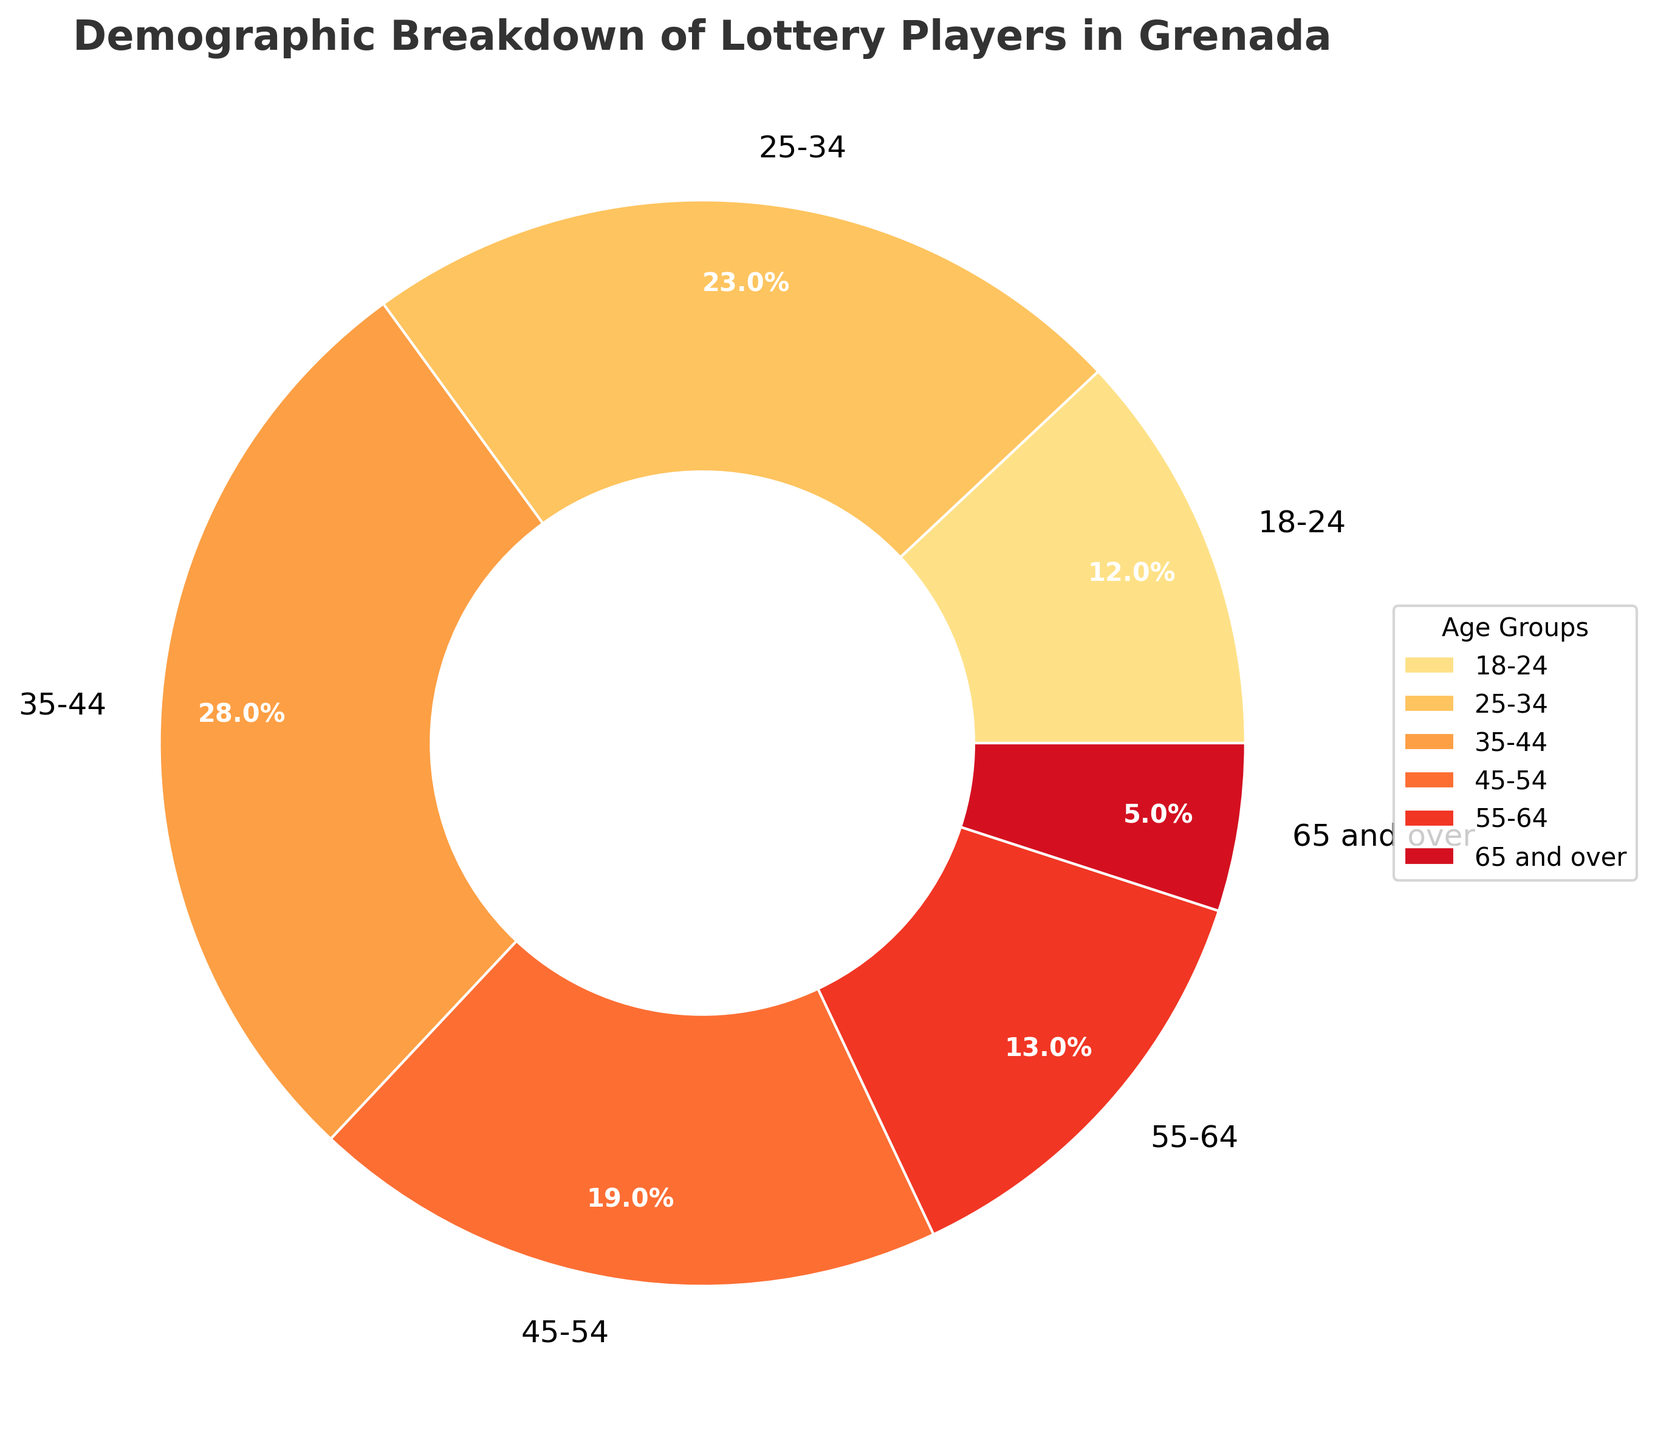Which age group has the highest percentage of lottery players? The pie chart shows the percentage breakdown of each age group. The age group 35-44 has the highest percentage of 28%.
Answer: 35-44 Which age group has the lowest percentage of lottery players? The pie chart shows the percentage breakdown of each age group. The age group 65 and over has the lowest percentage of 5%.
Answer: 65 and over What is the combined percentage of lottery players aged 35-44 and 45-54? The age group 35-44 has 28%, and the age group 45-54 has 19%. Adding these together gives 28% + 19% = 47%.
Answer: 47% Are there more lottery players in the 25-34 age group or the 55-64 age group? The pie chart shows the percentage of 25-34 age group is 23%, and the percentage of 55-64 age group is 13%. Therefore, there are more lottery players in the 25-34 age group.
Answer: 25-34 What is the percentage difference between the 18-24 age group and the 55-64 age group? The 18-24 age group has 12% and the 55-64 age group has 13%. The difference is 13% - 12% = 1%.
Answer: 1% Which age group has roughly double the percentage of players compared to the 18-24 age group? The 18-24 age group has 12%. The age group 25-34 has 23%, which is roughly double 12% (about 24%).
Answer: 25-34 How does the percentage of lottery players aged 45-54 compare to those aged 55-64? The 45-54 age group has 19% of players, while the 55-64 age group has 13%. Therefore, the 45-54 age group has a greater percentage.
Answer: 45-54 has more Which two age groups combined have a total percentage closest to 30%? The 18-24 age group has 12% and the 55-64 age group has 13%. Adding these together gives 12% + 13% = 25%. Combining the 18-24 age group (12%) and the 65 and over age group (5%) gives us 12% + 5% = 17%, which is less than 25%. Therefore, the groups combined closest to 30% are 55-64 and 18-24
Answer: 18-24 and 55-64 Which age group lies exactly at the median of the age groups shown in the pie chart? There are six age groups, and ordering them as 18-24, 25-34, 35-44, 45-54, 55-64, and 65 and over, the median is between the third (35-44) and fourth (45-54) groups. The average of their percentages (28% and 19%) doesn't change the middle position.
Answer: 35-44 and 45-54 What is the average percentage of lottery players for all age groups? The total percentage of all age groups combined is 100%. There are 6 age groups, so the average percentage is 100% / 6 = 16.67%.
Answer: 16.67% 